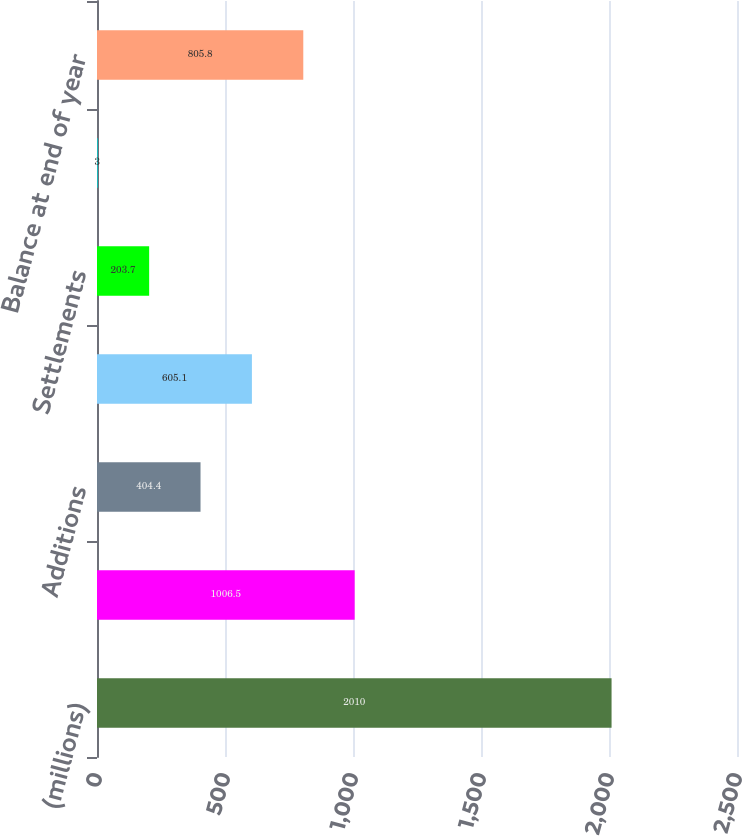<chart> <loc_0><loc_0><loc_500><loc_500><bar_chart><fcel>(millions)<fcel>Balance at beginning of year<fcel>Additions<fcel>Reductions<fcel>Settlements<fcel>Lapses in statutes of<fcel>Balance at end of year<nl><fcel>2010<fcel>1006.5<fcel>404.4<fcel>605.1<fcel>203.7<fcel>3<fcel>805.8<nl></chart> 